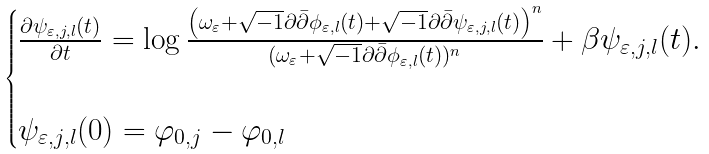<formula> <loc_0><loc_0><loc_500><loc_500>\begin{cases} \frac { \partial \psi _ { \varepsilon , j , l } ( t ) } { \partial t } = \log \frac { \left ( \omega _ { \varepsilon } + \sqrt { - 1 } \partial \bar { \partial } \phi _ { \varepsilon , l } ( t ) + \sqrt { - 1 } \partial \bar { \partial } \psi _ { \varepsilon , j , l } ( t ) \right ) ^ { n } } { ( \omega _ { \varepsilon } + \sqrt { - 1 } \partial \bar { \partial } \phi _ { \varepsilon , l } ( t ) ) ^ { n } } + \beta \psi _ { \varepsilon , j , l } ( t ) . \\ \\ \psi _ { \varepsilon , j , l } ( 0 ) = \varphi _ { 0 , j } - \varphi _ { 0 , l } \\ \end{cases}</formula> 